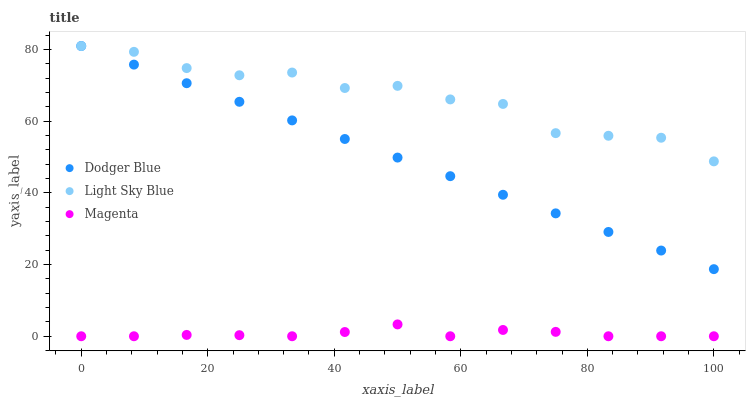Does Magenta have the minimum area under the curve?
Answer yes or no. Yes. Does Light Sky Blue have the maximum area under the curve?
Answer yes or no. Yes. Does Dodger Blue have the minimum area under the curve?
Answer yes or no. No. Does Dodger Blue have the maximum area under the curve?
Answer yes or no. No. Is Dodger Blue the smoothest?
Answer yes or no. Yes. Is Light Sky Blue the roughest?
Answer yes or no. Yes. Is Light Sky Blue the smoothest?
Answer yes or no. No. Is Dodger Blue the roughest?
Answer yes or no. No. Does Magenta have the lowest value?
Answer yes or no. Yes. Does Dodger Blue have the lowest value?
Answer yes or no. No. Does Dodger Blue have the highest value?
Answer yes or no. Yes. Does Light Sky Blue have the highest value?
Answer yes or no. No. Is Magenta less than Light Sky Blue?
Answer yes or no. Yes. Is Dodger Blue greater than Magenta?
Answer yes or no. Yes. Does Dodger Blue intersect Light Sky Blue?
Answer yes or no. Yes. Is Dodger Blue less than Light Sky Blue?
Answer yes or no. No. Is Dodger Blue greater than Light Sky Blue?
Answer yes or no. No. Does Magenta intersect Light Sky Blue?
Answer yes or no. No. 